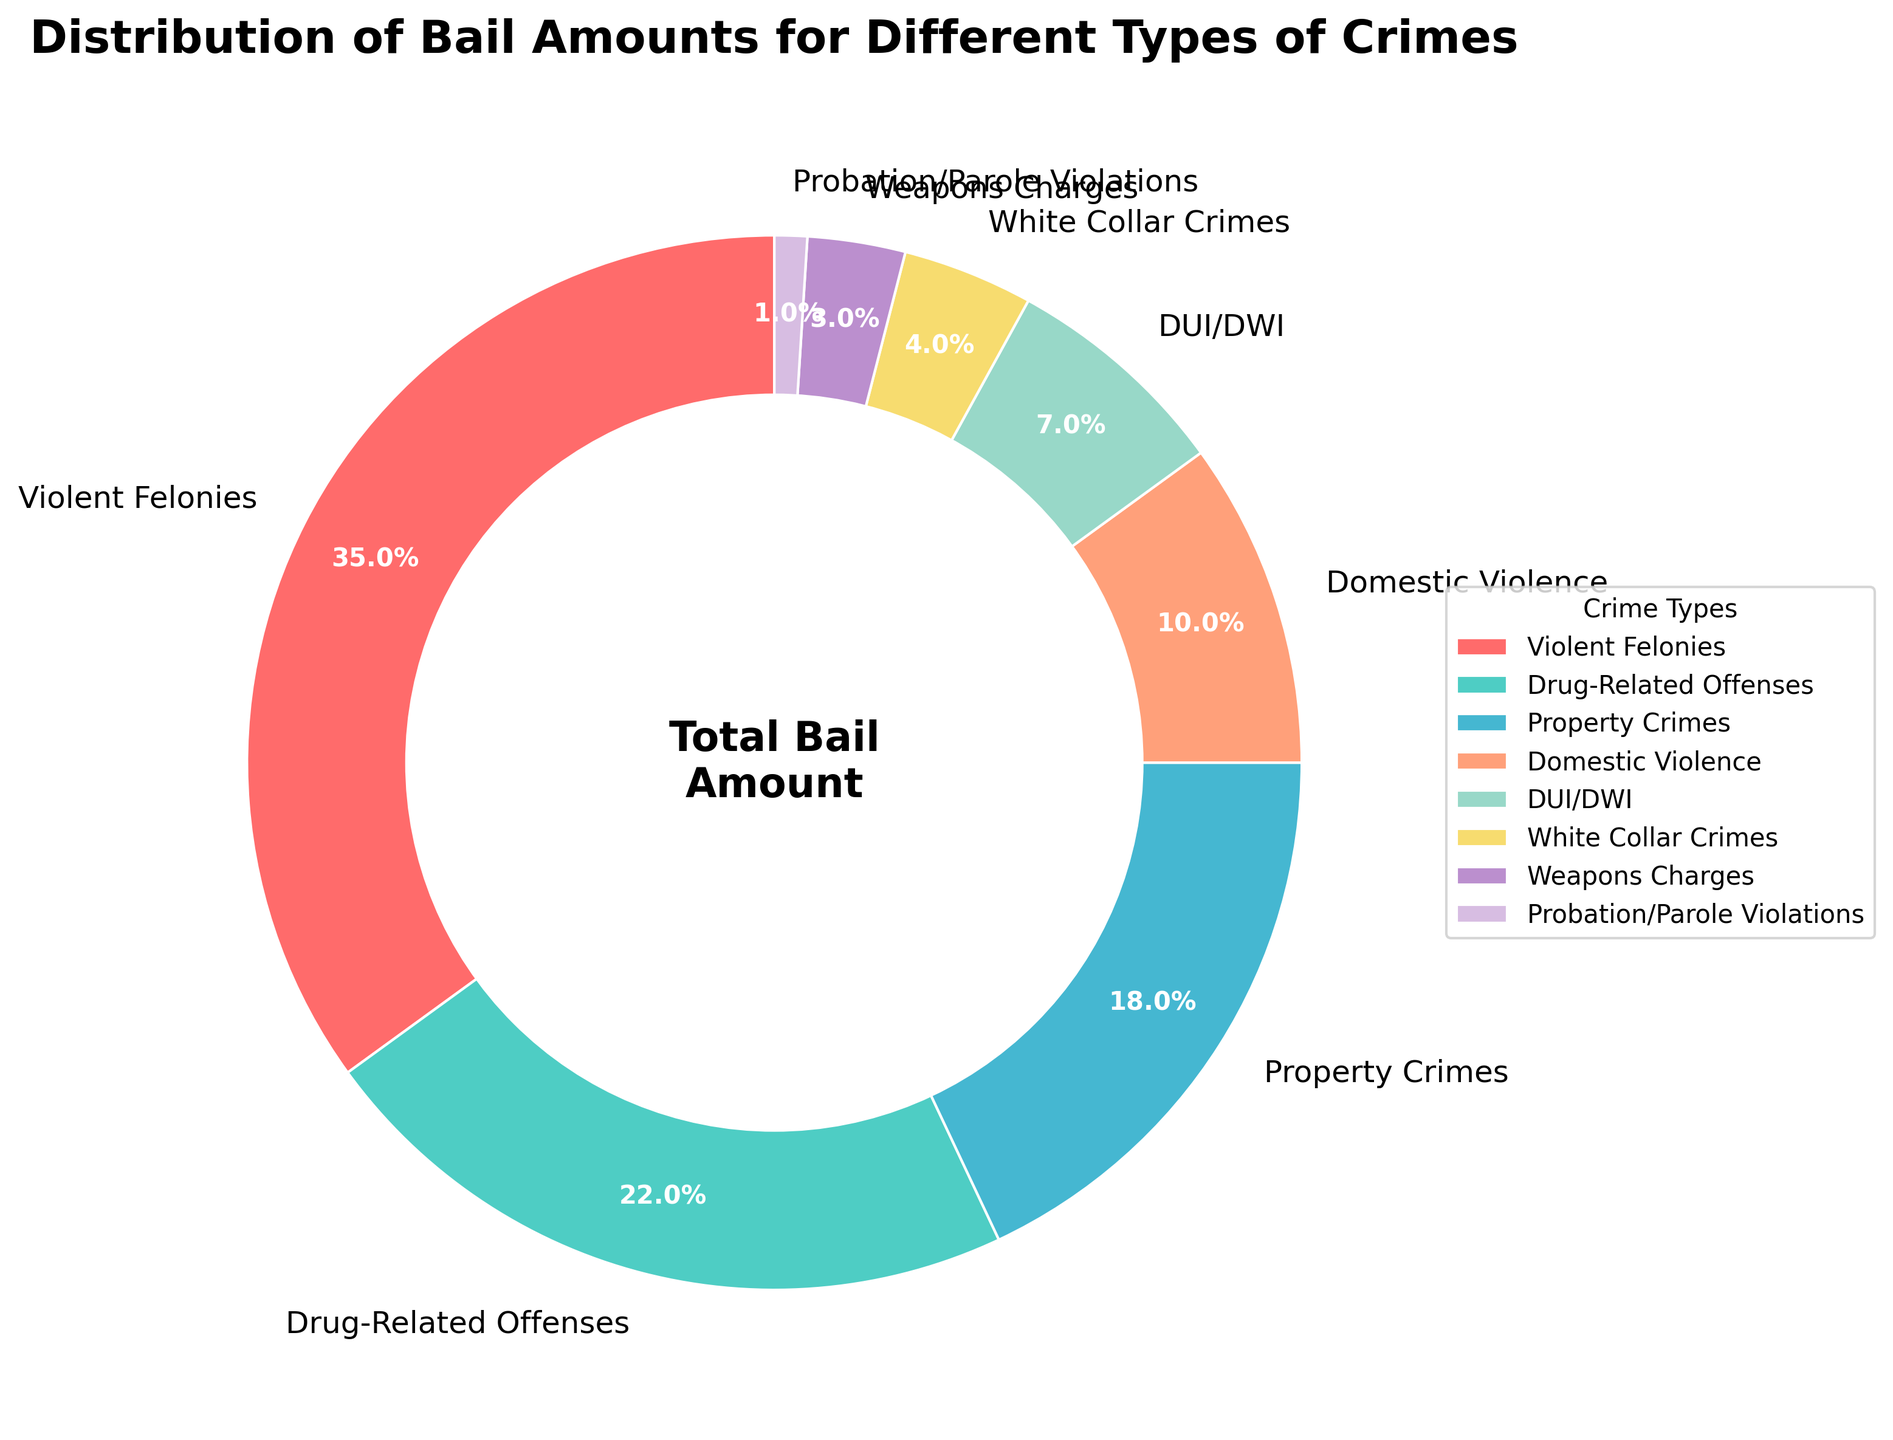Which crime type has the highest percentage of the total bail amount? The figure shows that Violent Felonies occupy the largest segment of the pie chart. This segment is labeled with 35%.
Answer: Violent Felonies What is the combined percentage of the total bail amount for Drug-Related Offenses and Property Crimes? From the chart, Drug-Related Offenses are 22% and Property Crimes are 18%. Adding them together gives 22% + 18% = 40%.
Answer: 40% Which segment is smaller: DUI/DWI or Domestic Violence? By comparing the sizes of the segments in the pie chart, DUI/DWI is labeled as 7%, while Domestic Violence is labeled as 10%. Therefore, DUI/DWI is smaller.
Answer: DUI/DWI What percentage of the total bail amount is set for White Collar Crimes? The segment for White Collar Crimes is labeled with 4%.
Answer: 4% How many crime types have a percentage of the total bail amount that is less than 10%? The segments for DUI/DWI, White Collar Crimes, Weapons Charges, and Probation/Parole Violations have percentages of 7%, 4%, 3%, and 1% respectively. Therefore, 4 crime types have a percentage less than 10%.
Answer: 4 What is the difference in the total bail amount percentage between Violent Felonies and Drug-Related Offenses? The percentage for Violent Felonies is 35% and for Drug-Related Offenses is 22%. Subtracting them gives 35% - 22% = 13%.
Answer: 13% Which two crime types together make up more than 50% of the total bail amount? By adding the percentages of the largest crime types, Violent Felonies (35%) and Drug-Related Offenses (22%), we get 35% + 22% = 57%. This is more than 50%.
Answer: Violent Felonies and Drug-Related Offenses How does the size of the segment for Domestic Violence compare to the combined size of Weapons Charges and Probation/Parole Violations? Domestic Violence is 10%, while the combined size of Weapons Charges (3%) and Probation/Parole Violations (1%) is 4%. Therefore, Domestic Violence is larger than the combined size of Weapons Charges and Probation/Parole Violations.
Answer: Domestic Violence is larger What color is used to represent Property Crimes in the pie chart? Property Crimes are represented with a light blue color (assuming that the default color assignment order is followed and colors are assigned in the order of the data listing).
Answer: light blue 